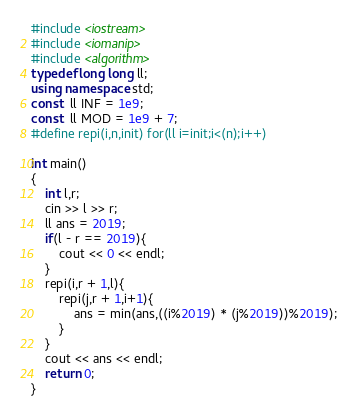Convert code to text. <code><loc_0><loc_0><loc_500><loc_500><_C++_>#include <iostream>
#include <iomanip>
#include <algorithm>
typedef long long ll;
using namespace std;
const  ll INF = 1e9;
const  ll MOD = 1e9 + 7;
#define repi(i,n,init) for(ll i=init;i<(n);i++)

int main()
{
    int l,r;
    cin >> l >> r;
    ll ans = 2019;
    if(l - r == 2019){
        cout << 0 << endl;
    }
    repi(i,r + 1,l){
        repi(j,r + 1,i+1){
            ans = min(ans,((i%2019) * (j%2019))%2019);
        }
    }
    cout << ans << endl;
    return 0;
}</code> 